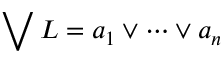Convert formula to latex. <formula><loc_0><loc_0><loc_500><loc_500>\bigvee L = a _ { 1 } \lor \cdots \lor a _ { n }</formula> 